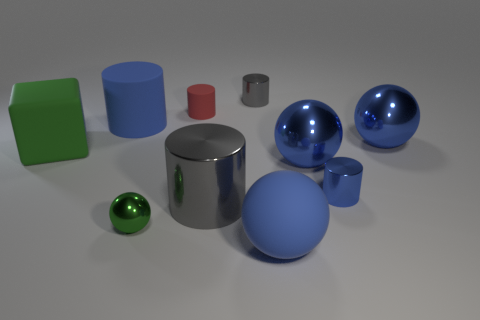Subtract all blue balls. How many were subtracted if there are1blue balls left? 2 Subtract all purple cylinders. How many blue spheres are left? 3 Subtract all large shiny cylinders. How many cylinders are left? 4 Subtract all green spheres. How many spheres are left? 3 Subtract all brown spheres. Subtract all cyan cylinders. How many spheres are left? 4 Add 9 small gray balls. How many small gray balls exist? 9 Subtract 0 cyan cylinders. How many objects are left? 10 Subtract all blocks. How many objects are left? 9 Subtract all big brown matte cylinders. Subtract all tiny gray cylinders. How many objects are left? 9 Add 2 small green metal spheres. How many small green metal spheres are left? 3 